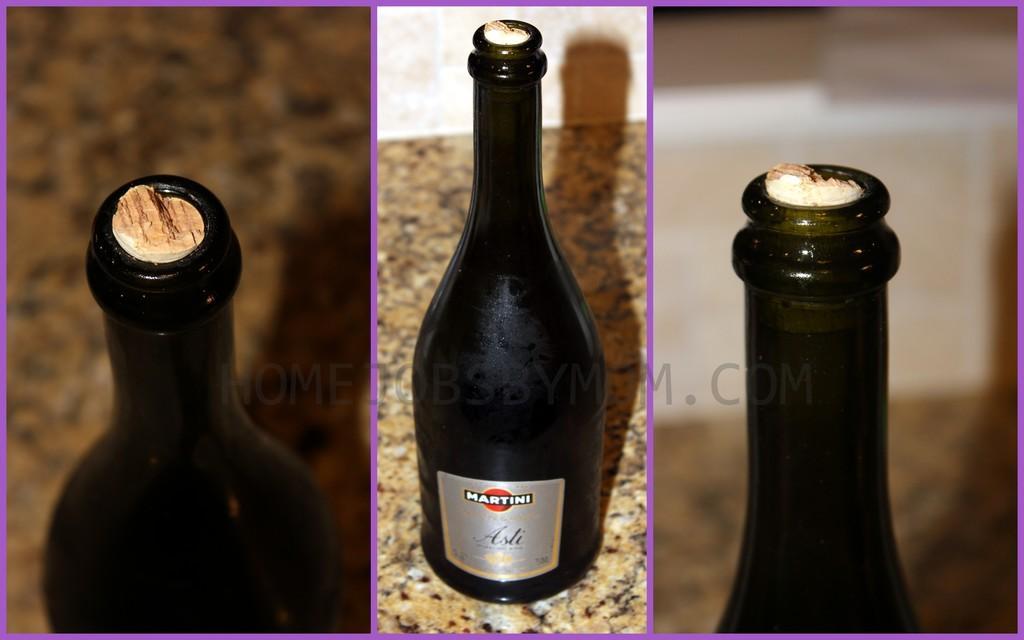How would you summarize this image in a sentence or two? This is collage picture, in these pictures we can see bottles. In the background of the image it is blurry. 